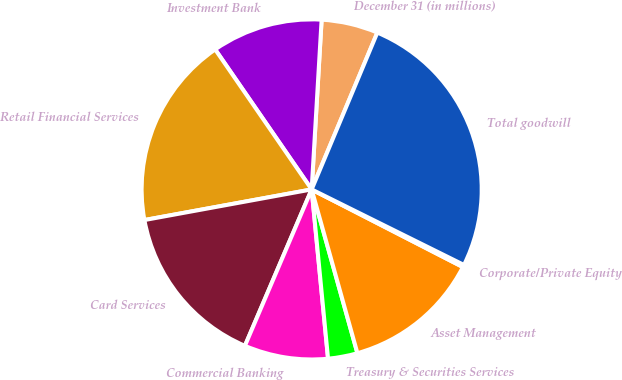Convert chart to OTSL. <chart><loc_0><loc_0><loc_500><loc_500><pie_chart><fcel>December 31 (in millions)<fcel>Investment Bank<fcel>Retail Financial Services<fcel>Card Services<fcel>Commercial Banking<fcel>Treasury & Securities Services<fcel>Asset Management<fcel>Corporate/Private Equity<fcel>Total goodwill<nl><fcel>5.38%<fcel>10.54%<fcel>18.28%<fcel>15.7%<fcel>7.96%<fcel>2.8%<fcel>13.12%<fcel>0.22%<fcel>26.02%<nl></chart> 